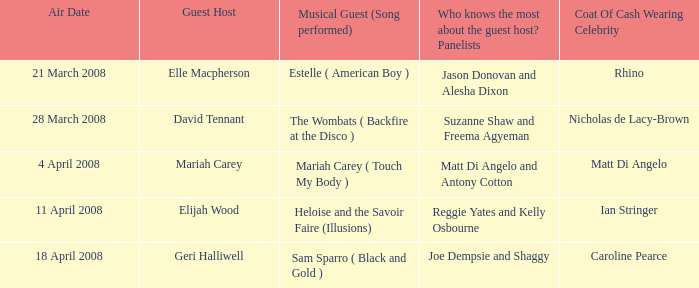Name the number of panelists for oat of cash wearing celebrity being matt di angelo 1.0. 